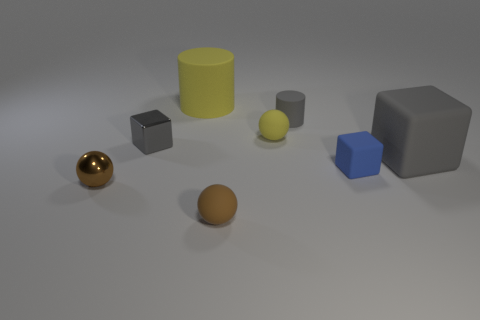What number of large rubber cubes are there?
Make the answer very short. 1. Does the block that is on the right side of the tiny blue matte block have the same material as the tiny gray block?
Provide a succinct answer. No. Is there a red shiny ball that has the same size as the yellow ball?
Give a very brief answer. No. Is the shape of the tiny yellow matte thing the same as the brown thing that is in front of the brown metallic thing?
Keep it short and to the point. Yes. There is a big rubber thing in front of the gray thing to the left of the gray cylinder; is there a tiny brown matte object that is to the right of it?
Your answer should be compact. No. The brown matte ball has what size?
Your answer should be very brief. Small. What number of other things are there of the same color as the small rubber cylinder?
Provide a short and direct response. 2. There is a gray matte object left of the small matte cube; is its shape the same as the large gray object?
Your answer should be very brief. No. What color is the shiny thing that is the same shape as the brown matte object?
Give a very brief answer. Brown. There is a metal thing that is the same shape as the tiny blue rubber thing; what is its size?
Ensure brevity in your answer.  Small. 